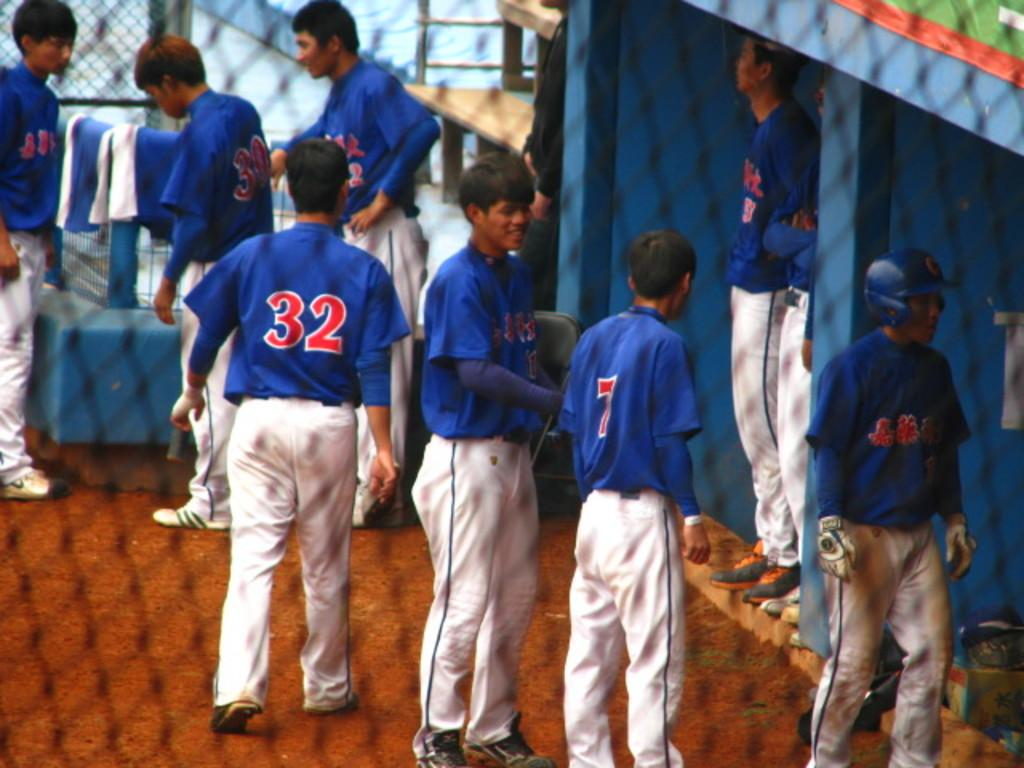<image>
Render a clear and concise summary of the photo. some players that have numbers on their back including 7 